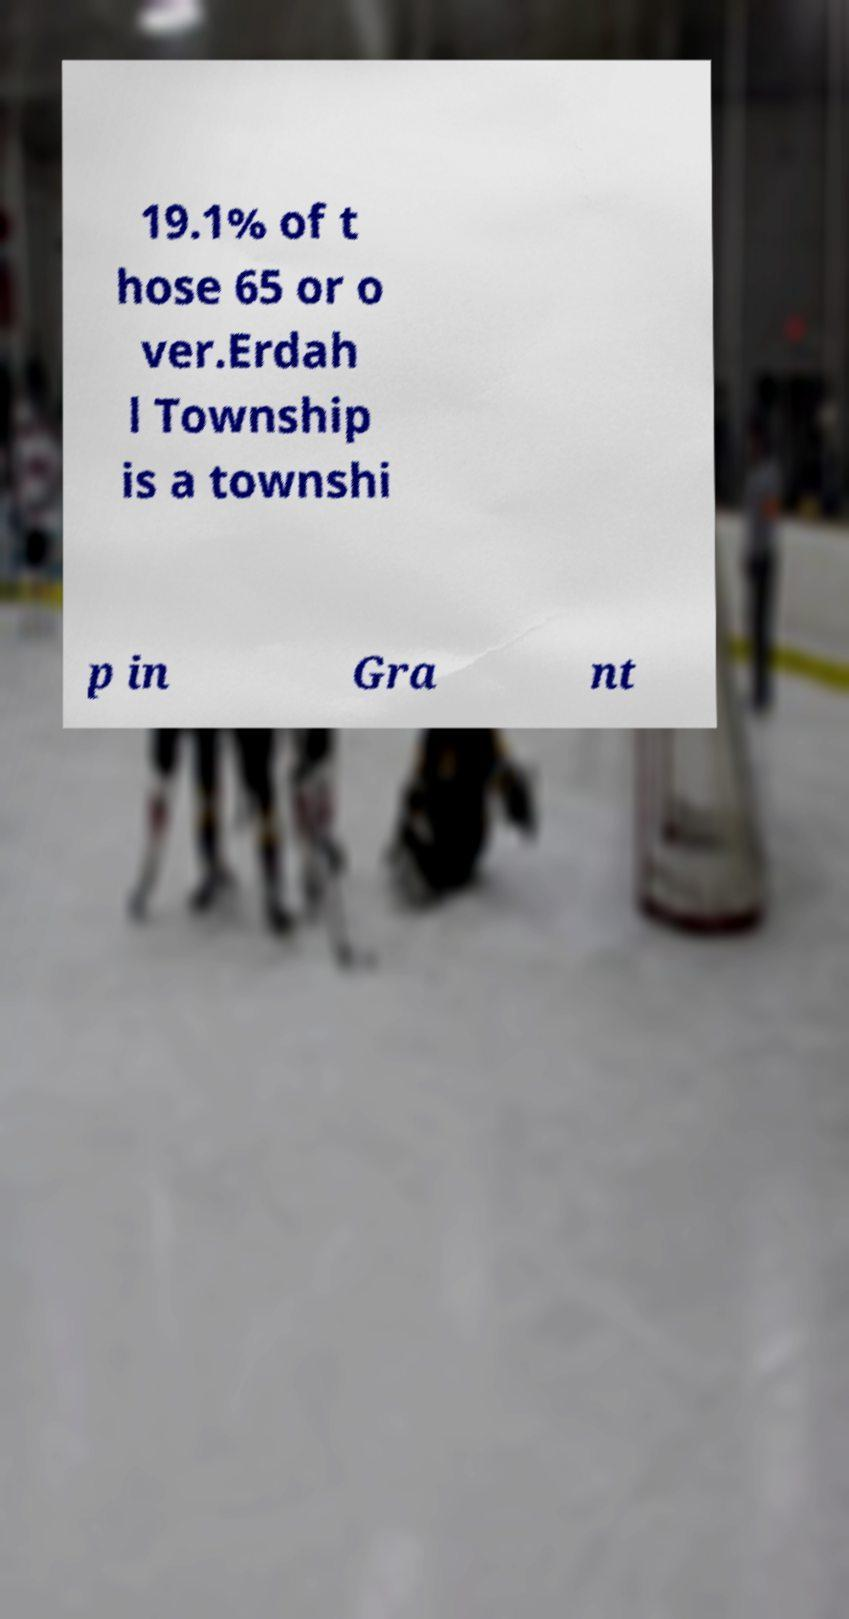What messages or text are displayed in this image? I need them in a readable, typed format. 19.1% of t hose 65 or o ver.Erdah l Township is a townshi p in Gra nt 